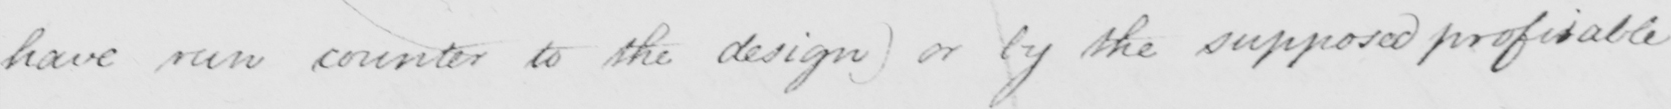What does this handwritten line say? have run counter to the design) or by the supposed profitable 